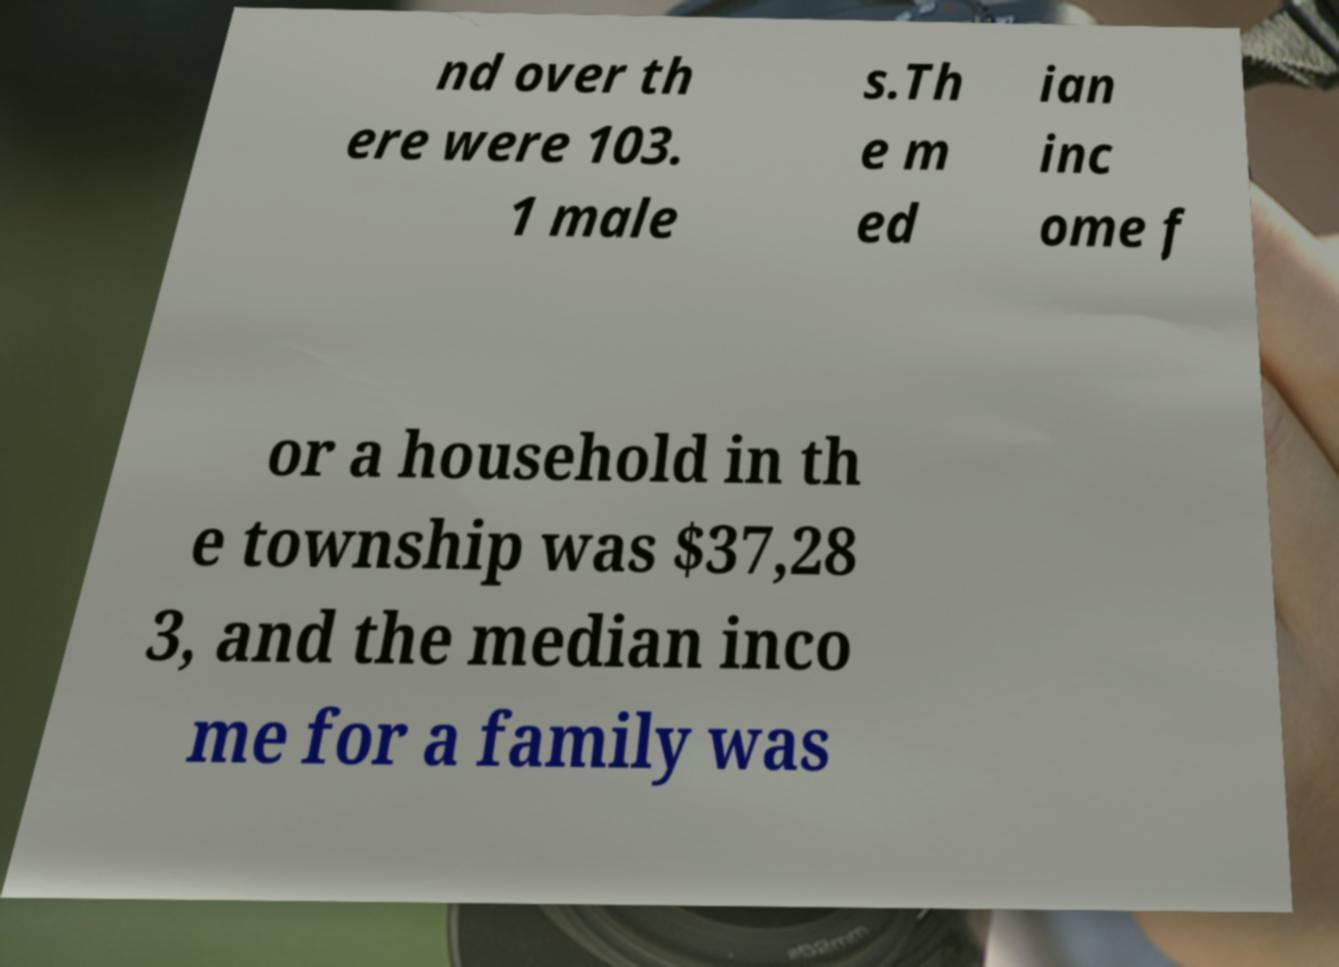There's text embedded in this image that I need extracted. Can you transcribe it verbatim? nd over th ere were 103. 1 male s.Th e m ed ian inc ome f or a household in th e township was $37,28 3, and the median inco me for a family was 